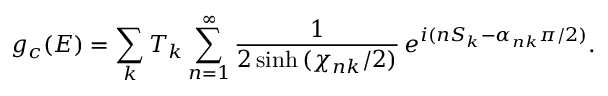<formula> <loc_0><loc_0><loc_500><loc_500>g _ { c } ( E ) = \sum _ { k } T _ { k } \sum _ { n = 1 } ^ { \infty } { \frac { 1 } { 2 \sinh { ( \chi _ { n k } / 2 ) } } } \, e ^ { i ( n S _ { k } - \alpha _ { n k } \pi / 2 ) } .</formula> 